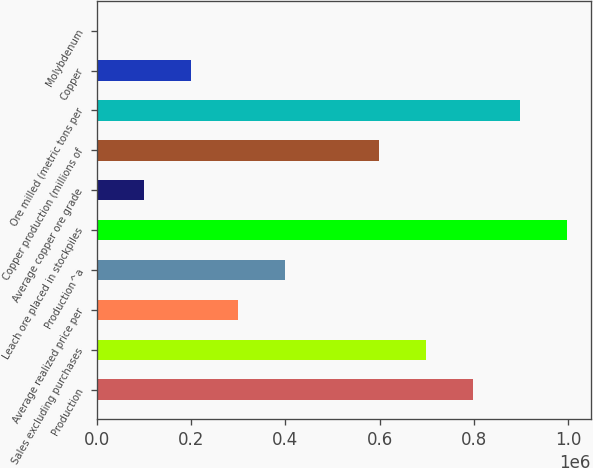Convert chart. <chart><loc_0><loc_0><loc_500><loc_500><bar_chart><fcel>Production<fcel>Sales excluding purchases<fcel>Average realized price per<fcel>Production^a<fcel>Leach ore placed in stockpiles<fcel>Average copper ore grade<fcel>Copper production (millions of<fcel>Ore milled (metric tons per<fcel>Copper<fcel>Molybdenum<nl><fcel>798880<fcel>699020<fcel>299580<fcel>399440<fcel>998600<fcel>99860<fcel>599160<fcel>898740<fcel>199720<fcel>0.03<nl></chart> 